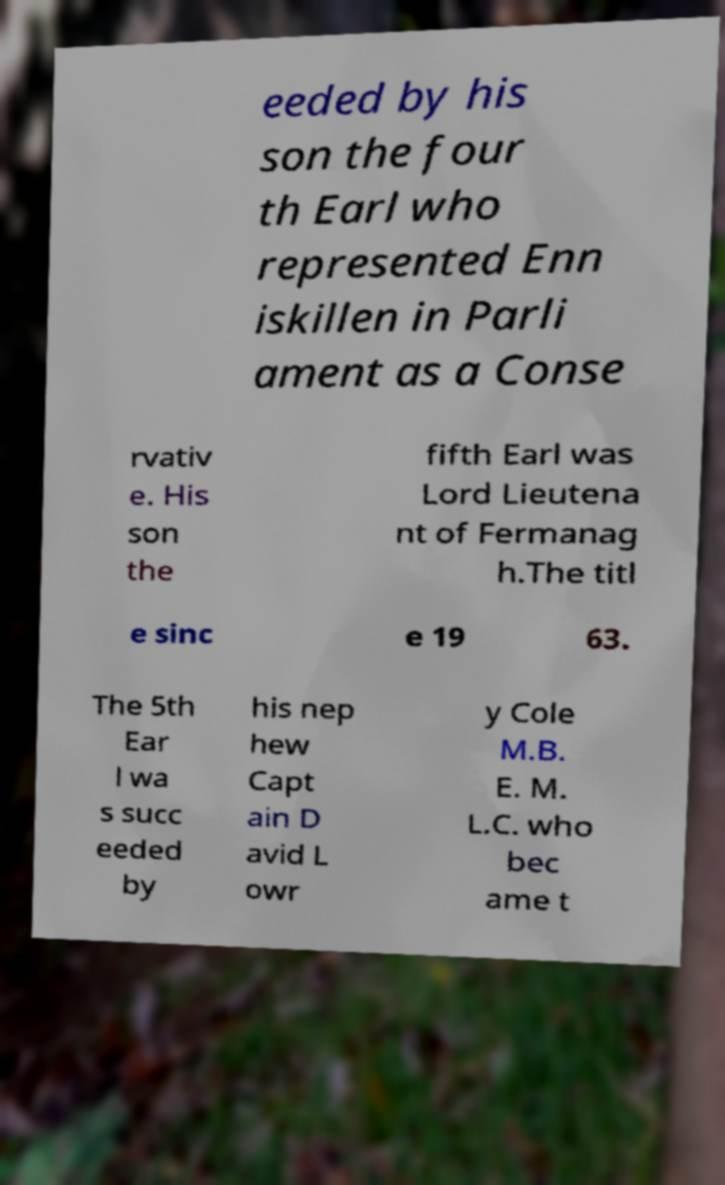Please read and relay the text visible in this image. What does it say? eeded by his son the four th Earl who represented Enn iskillen in Parli ament as a Conse rvativ e. His son the fifth Earl was Lord Lieutena nt of Fermanag h.The titl e sinc e 19 63. The 5th Ear l wa s succ eeded by his nep hew Capt ain D avid L owr y Cole M.B. E. M. L.C. who bec ame t 